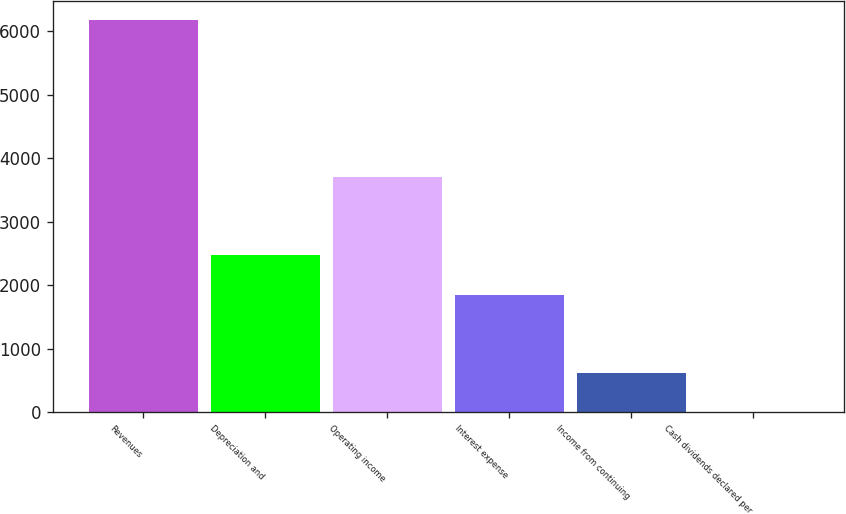Convert chart. <chart><loc_0><loc_0><loc_500><loc_500><bar_chart><fcel>Revenues<fcel>Depreciation and<fcel>Operating income<fcel>Interest expense<fcel>Income from continuing<fcel>Cash dividends declared per<nl><fcel>6172<fcel>2469.45<fcel>3703.63<fcel>1852.36<fcel>618.18<fcel>1.09<nl></chart> 